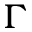<formula> <loc_0><loc_0><loc_500><loc_500>\Gamma</formula> 